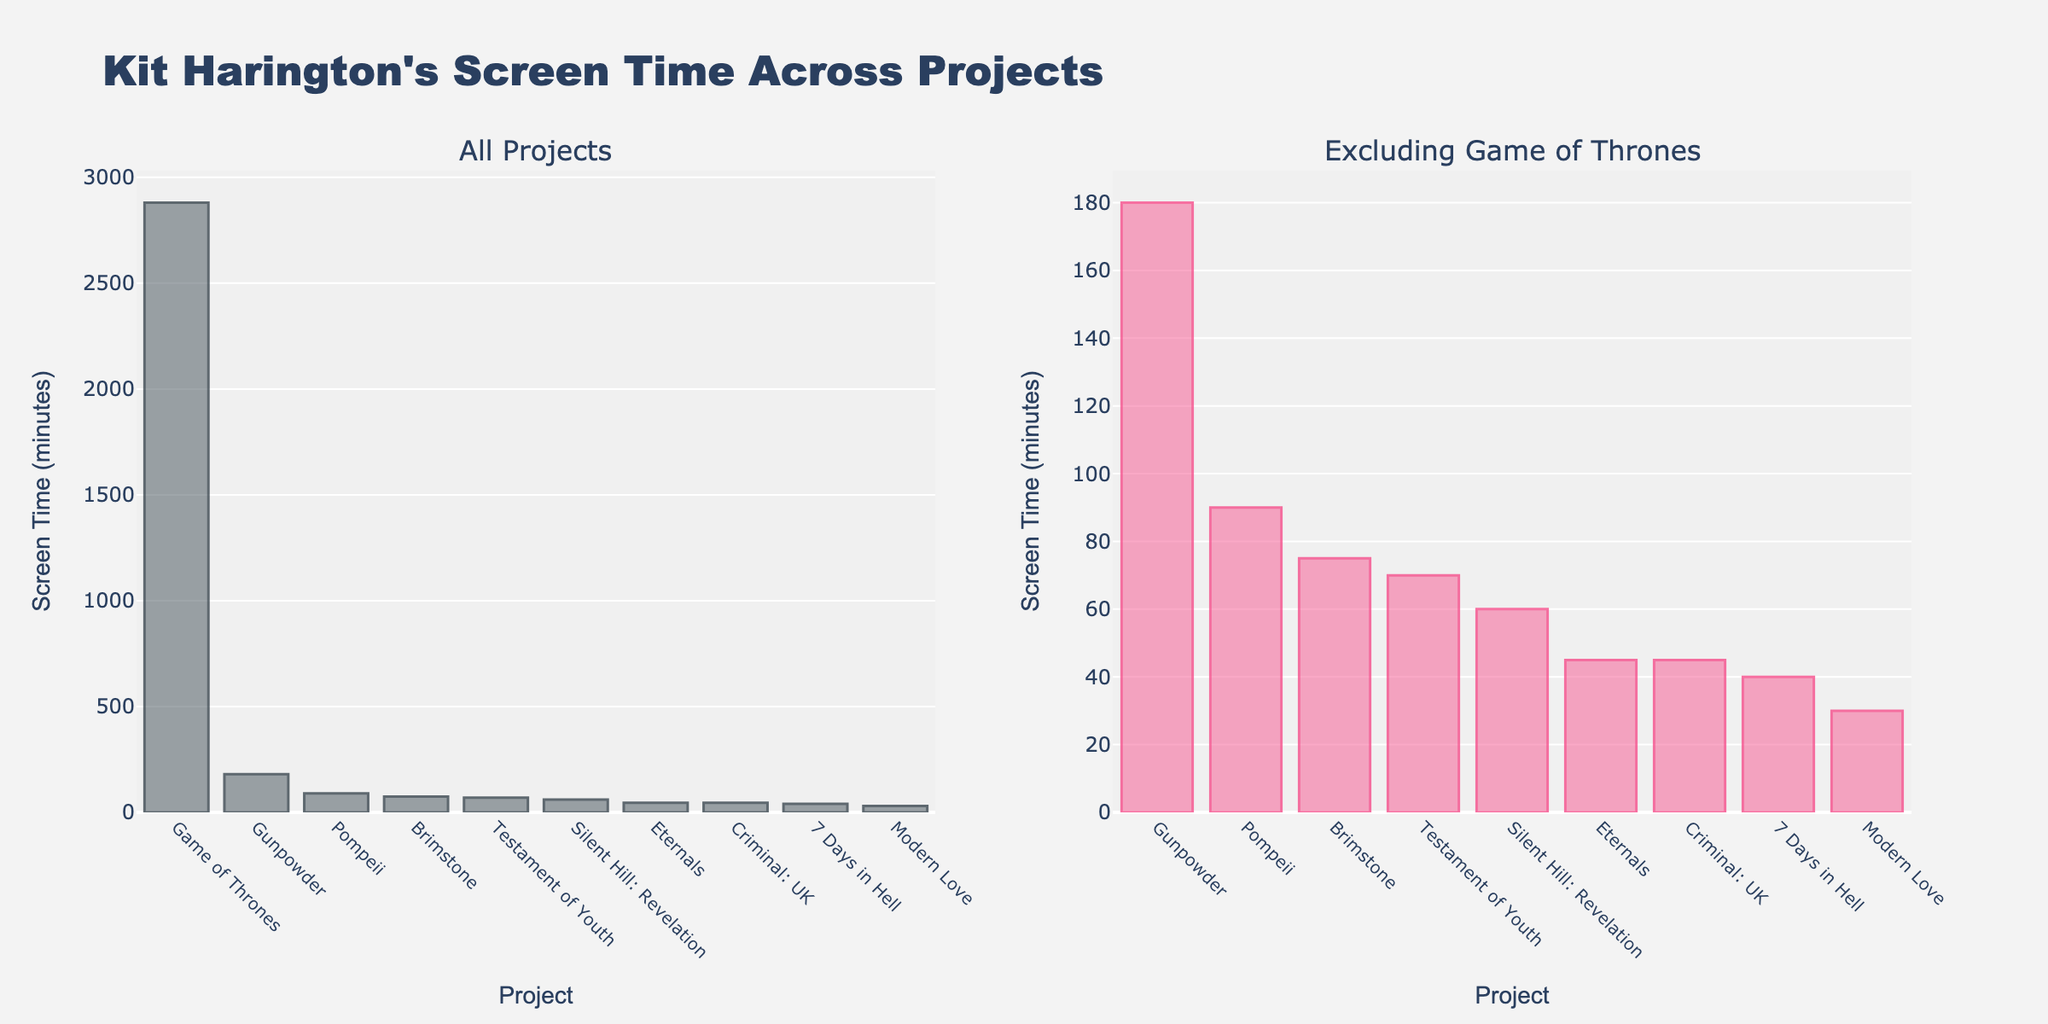what is the title of the plot? The title is usually displayed at the top of the figure. In this case, it reads "Kit Harington's Screen Time Across Projects."
Answer: Kit Harington's Screen Time Across Projects Which project shows the highest screen time in the plot on the left? The left plot includes all projects, and the highest bar corresponds to "Game of Thrones."
Answer: Game of Thrones How many projects exclude "Game of Thrones" in the right subplot? The right subplot excludes "Game of Thrones." Counting the bars in this plot gives us the number of projects displayed. There are 9 bars.
Answer: 9 By how many minutes does "Game of Thrones" exceed the second-highest screen time project? In the left subplot, "Game of Thrones" has 2880 minutes. The next highest is "Gunpowder" with 180 minutes. The difference is 2880 - 180 = 2700 minutes.
Answer: 2700 minutes Which project has the least screen time when "Game of Thrones" is excluded? The right subplot excludes "Game of Thrones." The shortest bar here represents "Modern Love," with 30 minutes.
Answer: Modern Love What is the total screen time for "Gunpowder" and "Eternals" combined? Check each subplot for their screen times: "Gunpowder" has 180 minutes and "Eternals" has 45 minutes. Summing them gives 180 + 45 = 225 minutes.
Answer: 225 minutes Which project is just below "Gunpowder" in screen time? In the left subplot, under "Gunpowder" (180 minutes) is "Pompeii" with 90 minutes.
Answer: Pompeii Compare the screen time of "Pompeii" to "Brimstone." Which has more? Compared to "Brimstone" with 75 minutes, "Pompeii" has 90 minutes, which is more.
Answer: Pompeii What is the average screen time of all projects excluding "Game of Thrones"? Refer to the right subplot: sum all the screen times (45 + 90 + 60 + 180 + 30 + 45 + 40 + 75 + 70) = 635 minutes. There are 9 projects, so the average is 635 / 9 ≈ 70.56 minutes.
Answer: 70.56 minutes How does the screen time of "Testament of Youth" and "7 Days in Hell" compare? "Testament of Youth" has 70 minutes, and "7 Days in Hell" has 40 minutes. "Testament of Youth" has more.
Answer: Testament of Youth 